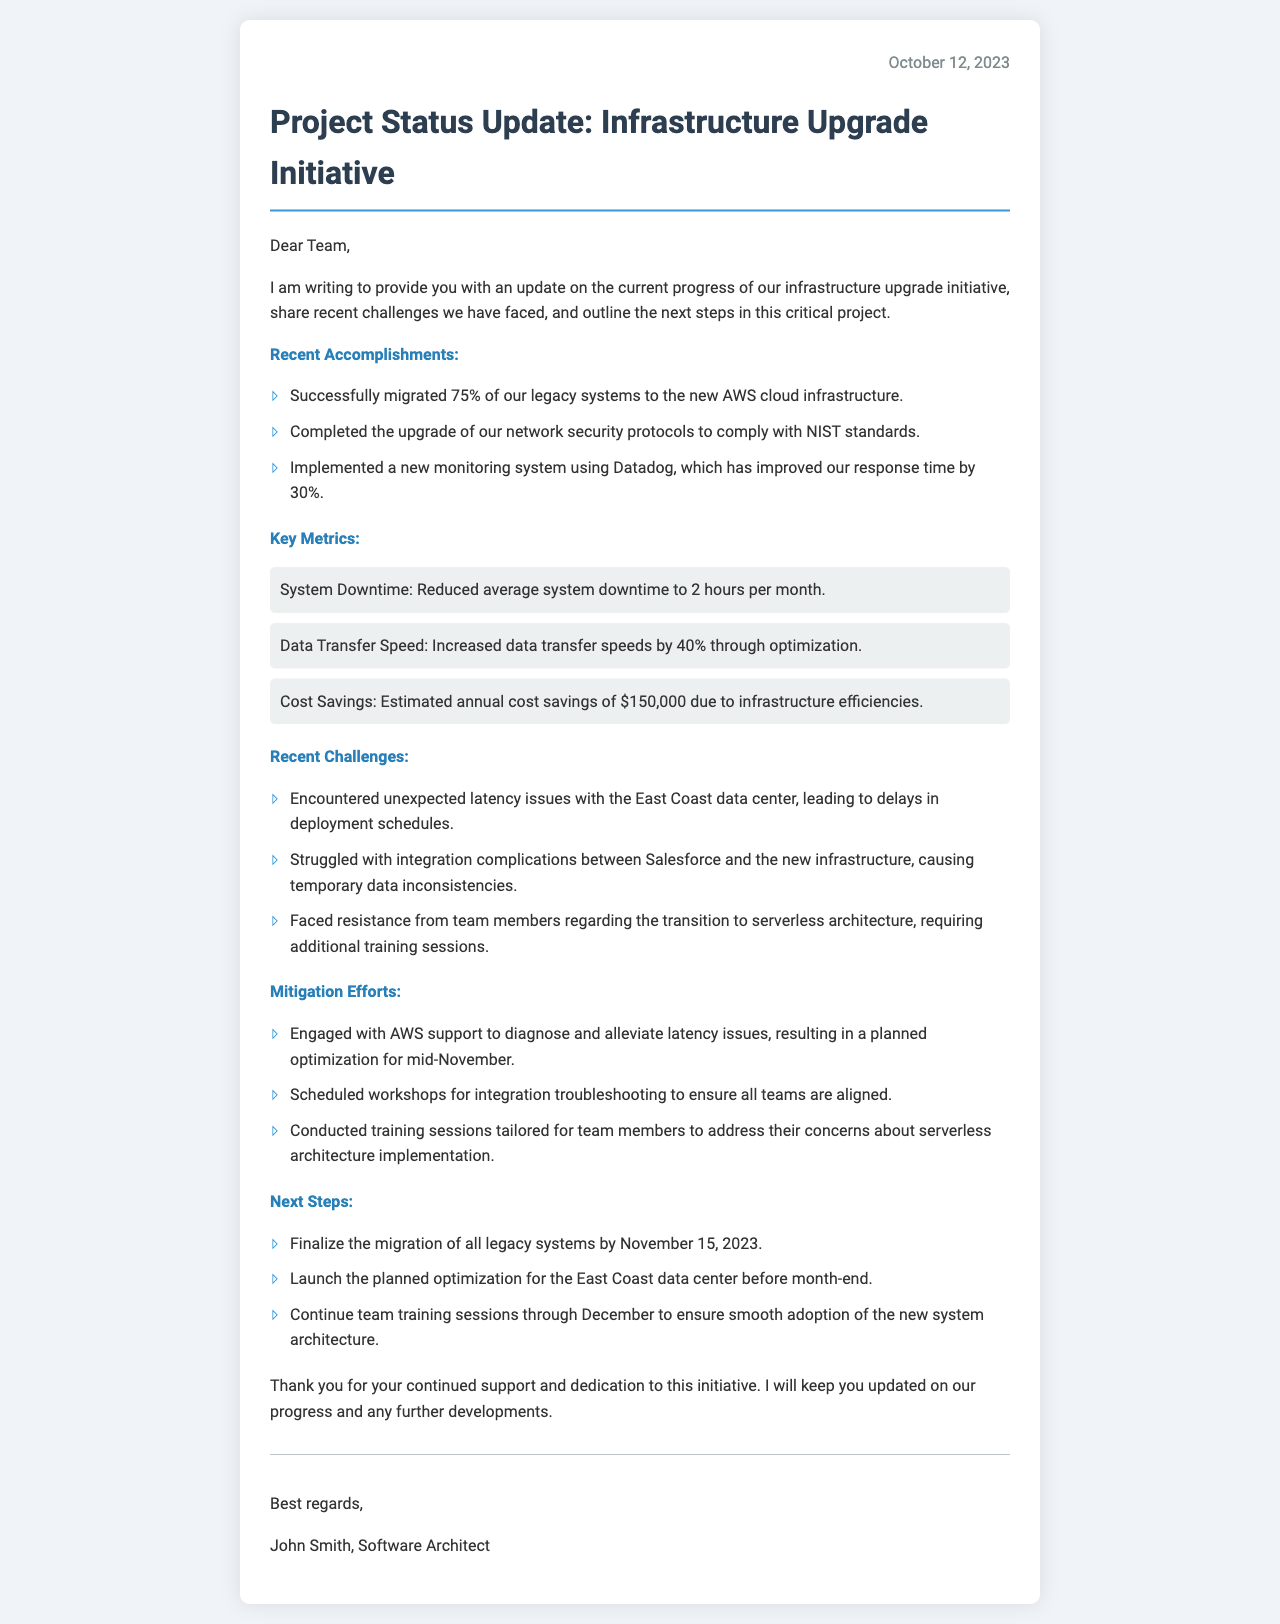What is the date of the status update? The letter is dated October 12, 2023, as stated at the top of the document.
Answer: October 12, 2023 What percentage of legacy systems has been migrated? The document states that 75% of legacy systems have been migrated to the new infrastructure.
Answer: 75% What is the estimated annual cost savings mentioned? Key metrics in the document specify an estimated annual cost savings due to efficiencies in the infrastructure.
Answer: $150,000 What is one recent challenge faced regarding integration? The document mentions struggles with integration complications between Salesforce and the new infrastructure.
Answer: Integration complications with Salesforce What is the planned date for finalizing the migration of all legacy systems? The next steps in the letter specify that the migration of all legacy systems will be finalized by November 15, 2023.
Answer: November 15, 2023 What system has been implemented to improve response time? The letter indicates that a new monitoring system using Datadog has been implemented.
Answer: Datadog What is mentioned as a mitigation effort for latency issues? The document describes engagement with AWS support to diagnose and alleviate latency issues as a mitigation effort.
Answer: AWS support engagement What will continue through December according to the next steps? The next steps outline that team training sessions will continue through December to ensure smooth adoption.
Answer: Team training sessions 